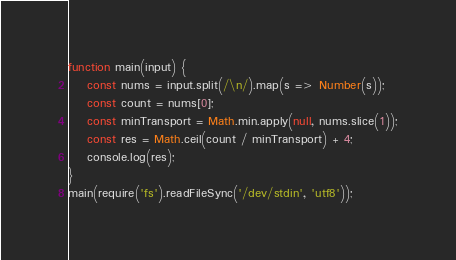<code> <loc_0><loc_0><loc_500><loc_500><_JavaScript_>function main(input) {
    const nums = input.split(/\n/).map(s => Number(s));
    const count = nums[0];
    const minTransport = Math.min.apply(null, nums.slice(1));
    const res = Math.ceil(count / minTransport) + 4;
    console.log(res);
}
main(require('fs').readFileSync('/dev/stdin', 'utf8'));</code> 